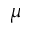<formula> <loc_0><loc_0><loc_500><loc_500>\mu</formula> 